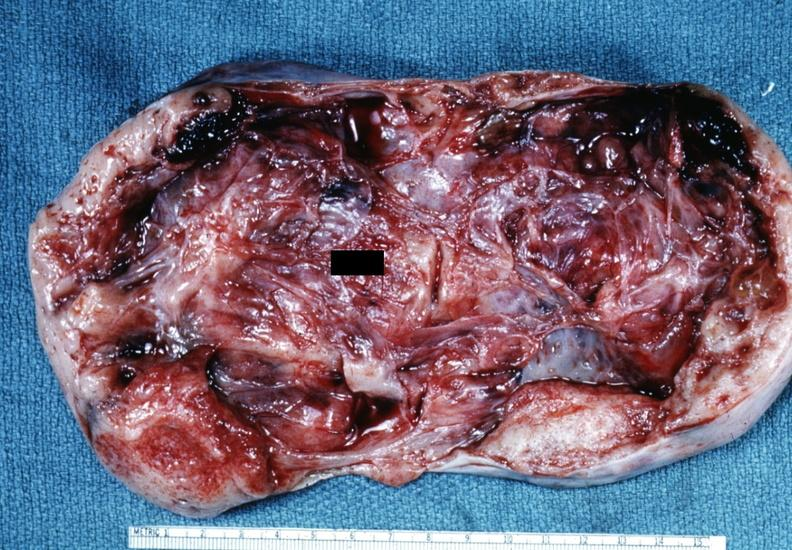s female reproductive present?
Answer the question using a single word or phrase. Yes 